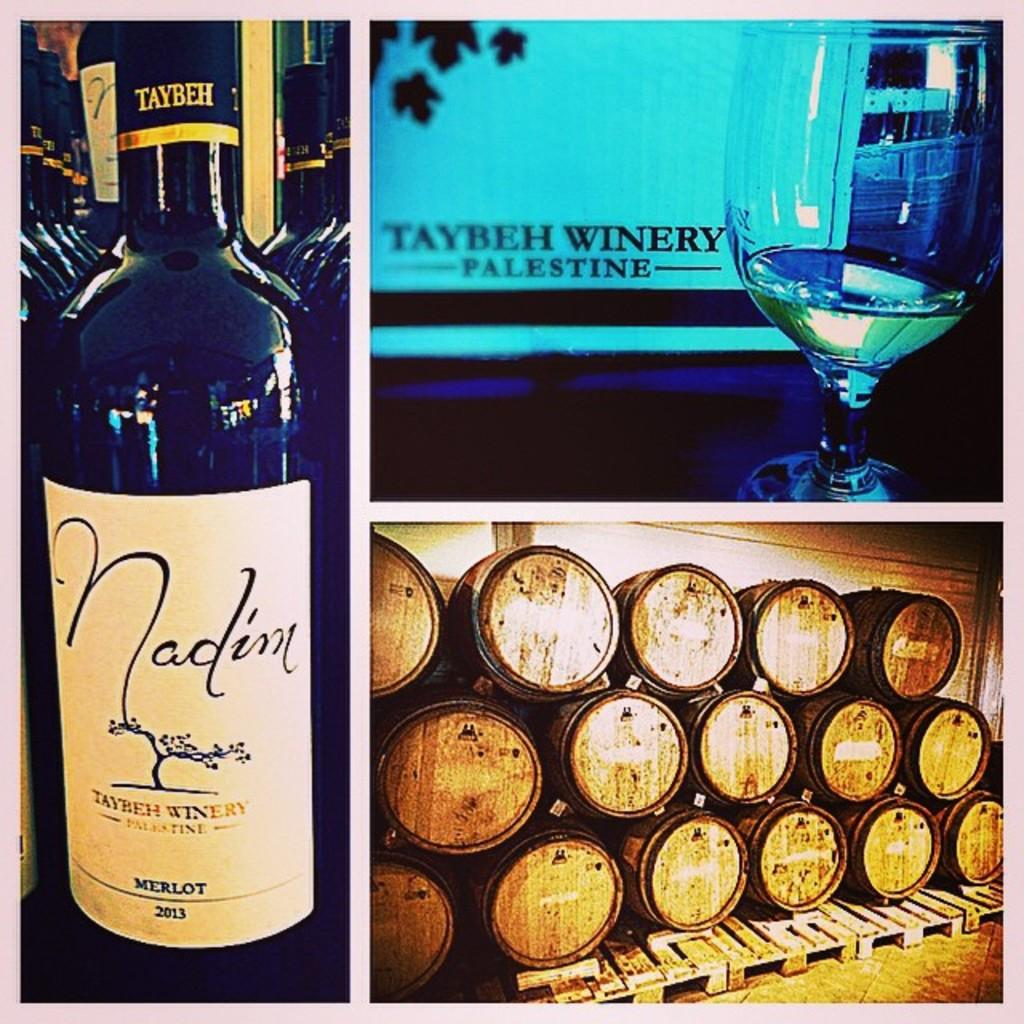<image>
Summarize the visual content of the image. A bottle of 2013 Merlot is to the left of a almost empty glass of wine and a lot of wine barrels. 